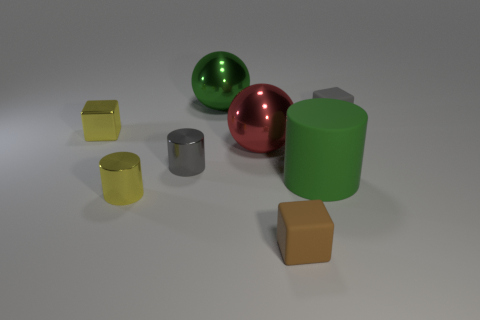Does the large green shiny object have the same shape as the gray shiny thing?
Provide a succinct answer. No. Is the number of shiny cubes that are behind the big cylinder less than the number of large red shiny things to the left of the tiny yellow shiny cube?
Make the answer very short. No. There is a gray block; how many gray rubber objects are to the right of it?
Your answer should be very brief. 0. There is a big object on the left side of the red metal object; is it the same shape as the gray object to the left of the small gray rubber cube?
Ensure brevity in your answer.  No. What number of other things are the same color as the small metal cube?
Give a very brief answer. 1. What material is the tiny gray object on the left side of the matte object in front of the large thing that is on the right side of the brown matte thing made of?
Make the answer very short. Metal. What material is the small object on the left side of the metallic cylinder in front of the gray cylinder made of?
Your answer should be compact. Metal. Is the number of tiny metal cylinders that are behind the gray cylinder less than the number of big red objects?
Ensure brevity in your answer.  Yes. There is a green object that is left of the brown cube; what is its shape?
Make the answer very short. Sphere. Do the green matte cylinder and the sphere behind the red shiny object have the same size?
Offer a terse response. Yes. 